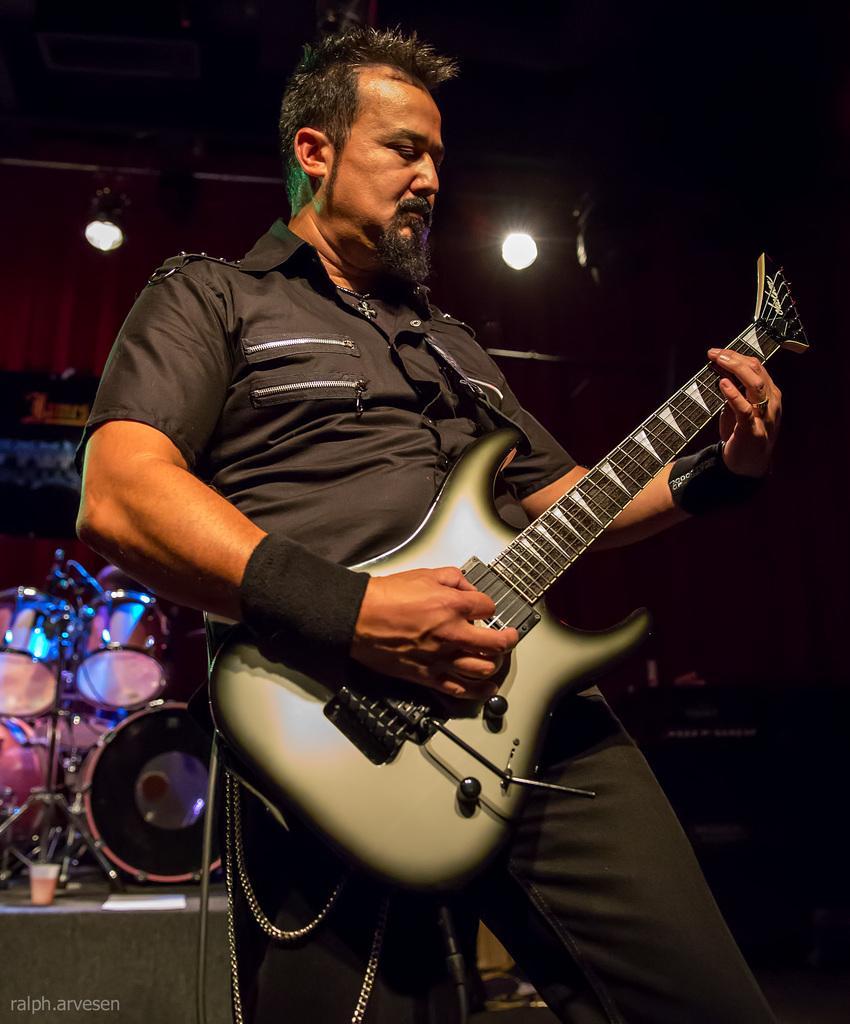Please provide a concise description of this image. In the image there is a man playing guitar and back side of him there is drum kit. 